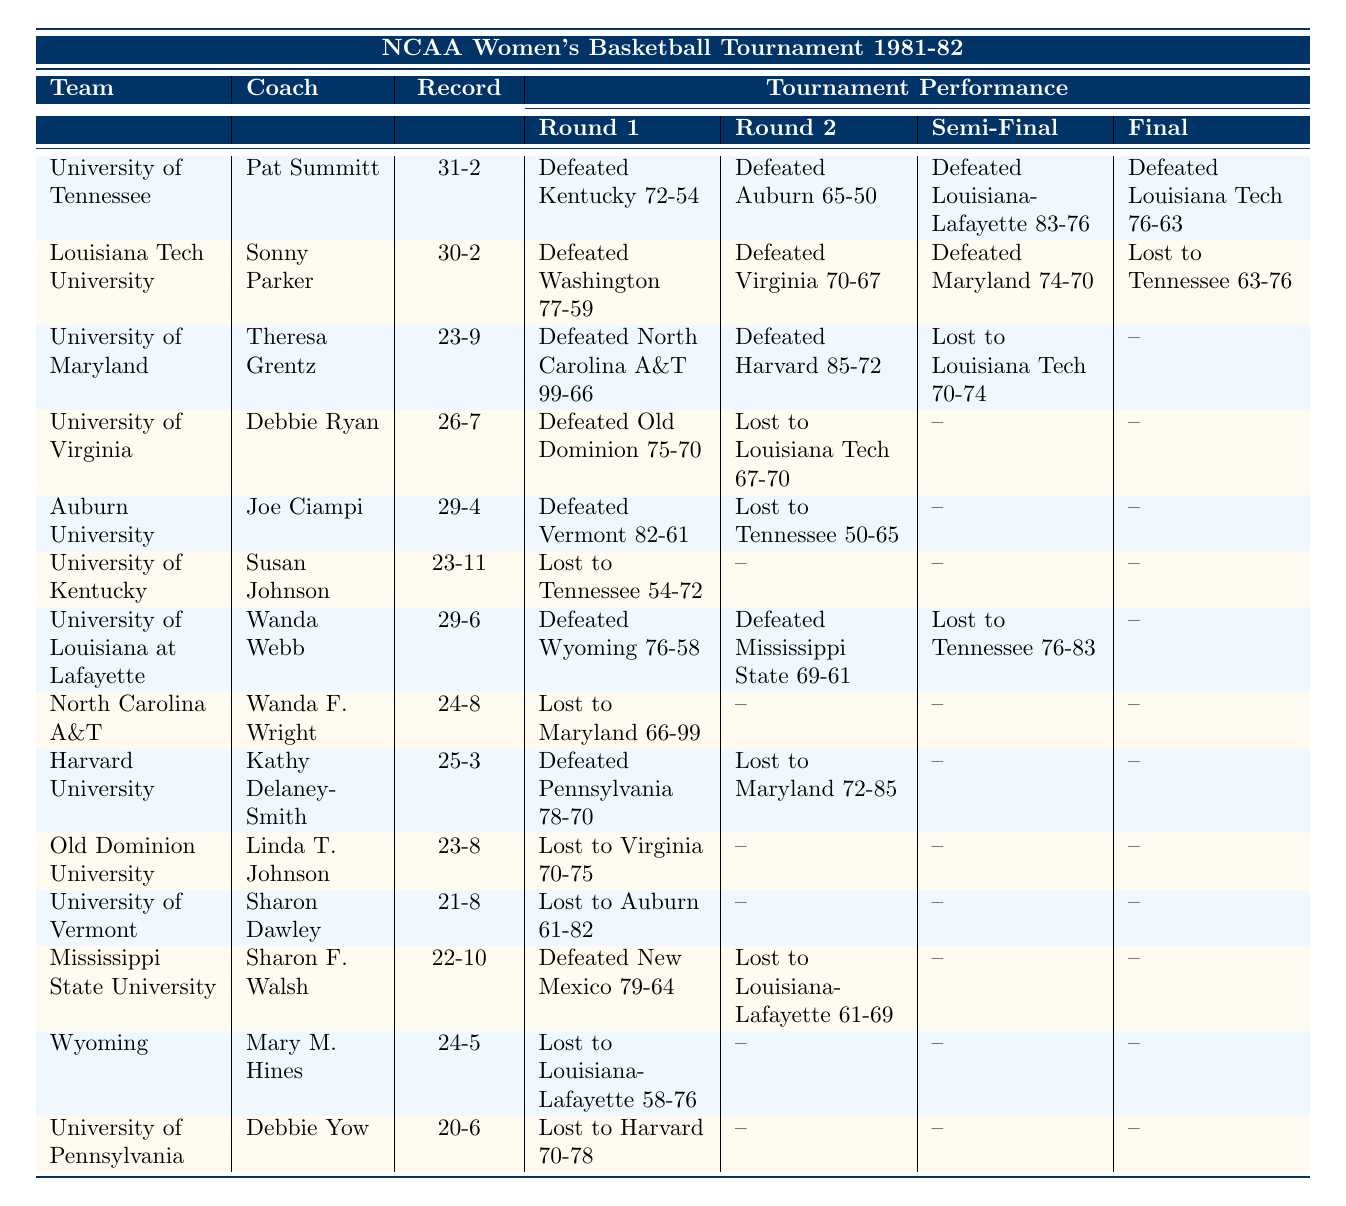What was the record of the University of Tennessee? The table shows the record of the University of Tennessee as 31-2.
Answer: 31-2 Who coached the Louisiana Tech University team? According to the table, the coach of Louisiana Tech University is Sonny Parker.
Answer: Sonny Parker Did the University of Maryland reach the final? The table indicates that the University of Maryland lost in the semi-final, so they did not reach the final.
Answer: No How many teams lost in the first round of the tournament? The teams that lost in the first round were University of Kentucky, North Carolina A&T, Old Dominion University, University of Vermont, and University of Pennsylvania. Counting these yields 5 teams.
Answer: 5 Who were the opponents of Auburn University in their tournament? Auburn University defeated University of Vermont in the first round and lost to University of Tennessee in the second round. They did not progress further.
Answer: Vermont, Tennessee Which team had the highest record before the tournament? The highest record was 31-2, held by the University of Tennessee.
Answer: University of Tennessee How many points did Louisiana Tech University score in the final? The table states that Louisiana Tech University scored 63 points in the final against the University of Tennessee.
Answer: 63 What was the result of the semi-final match involving University of Maryland? In the semi-final, the University of Maryland lost to Louisiana Tech University with a score of 70-74.
Answer: Lost to Louisiana Tech University Which team had the lowest win record in the tournament? The team with the lowest win record was the University of Pennsylvania, with a record of 20-6.
Answer: University of Pennsylvania How many teams did University of Tennessee defeat to win the tournament? The University of Tennessee defeated 4 teams: University of Kentucky, Auburn University, Louisiana at Lafayette, and Louisiana Tech University to win the tournament.
Answer: 4 Which teams defeated Louisiana Tech University in this tournament? Louisiana Tech University lost only in the final to the University of Tennessee. Therefore, they were never defeated by another team within the tournament.
Answer: None 